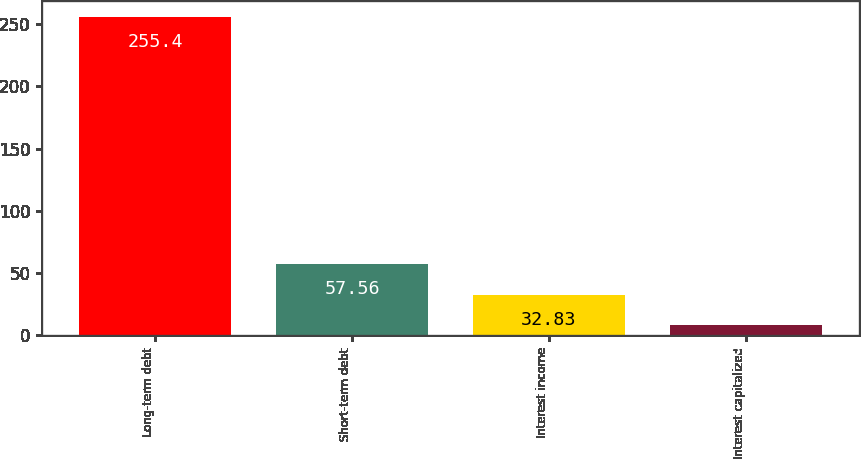<chart> <loc_0><loc_0><loc_500><loc_500><bar_chart><fcel>Long-term debt<fcel>Short-term debt<fcel>Interest income<fcel>Interest capitalized<nl><fcel>255.4<fcel>57.56<fcel>32.83<fcel>8.1<nl></chart> 